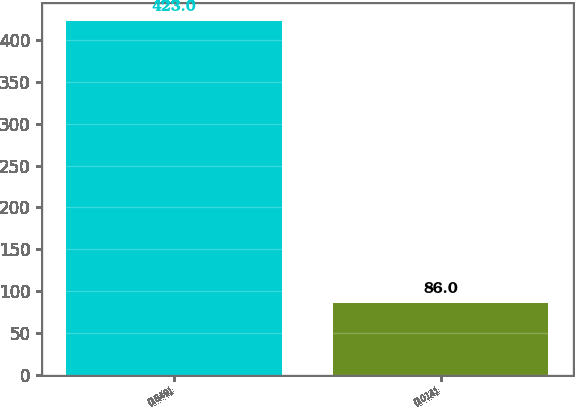<chart> <loc_0><loc_0><loc_500><loc_500><bar_chart><fcel>(1849)<fcel>(1014)<nl><fcel>423<fcel>86<nl></chart> 